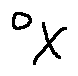Convert formula to latex. <formula><loc_0><loc_0><loc_500><loc_500>o _ { X }</formula> 